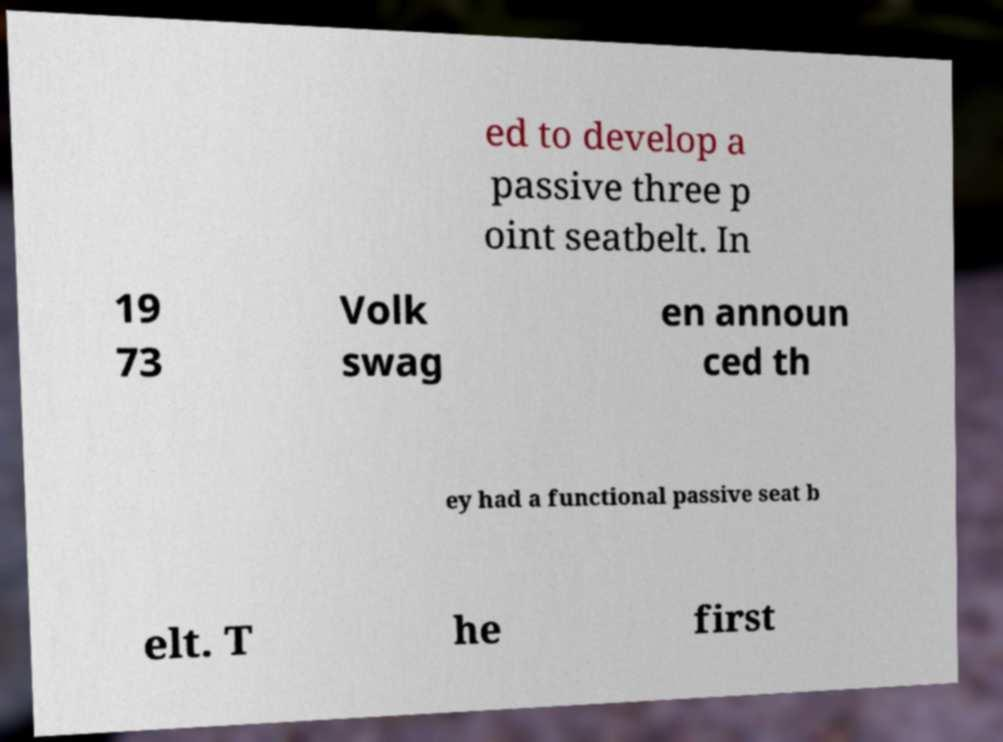Please identify and transcribe the text found in this image. ed to develop a passive three p oint seatbelt. In 19 73 Volk swag en announ ced th ey had a functional passive seat b elt. T he first 